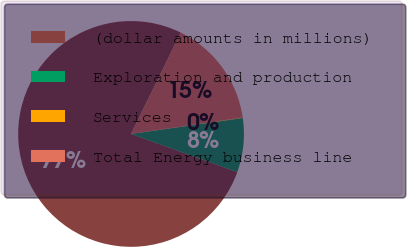Convert chart to OTSL. <chart><loc_0><loc_0><loc_500><loc_500><pie_chart><fcel>(dollar amounts in millions)<fcel>Exploration and production<fcel>Services<fcel>Total Energy business line<nl><fcel>76.77%<fcel>7.74%<fcel>0.08%<fcel>15.41%<nl></chart> 